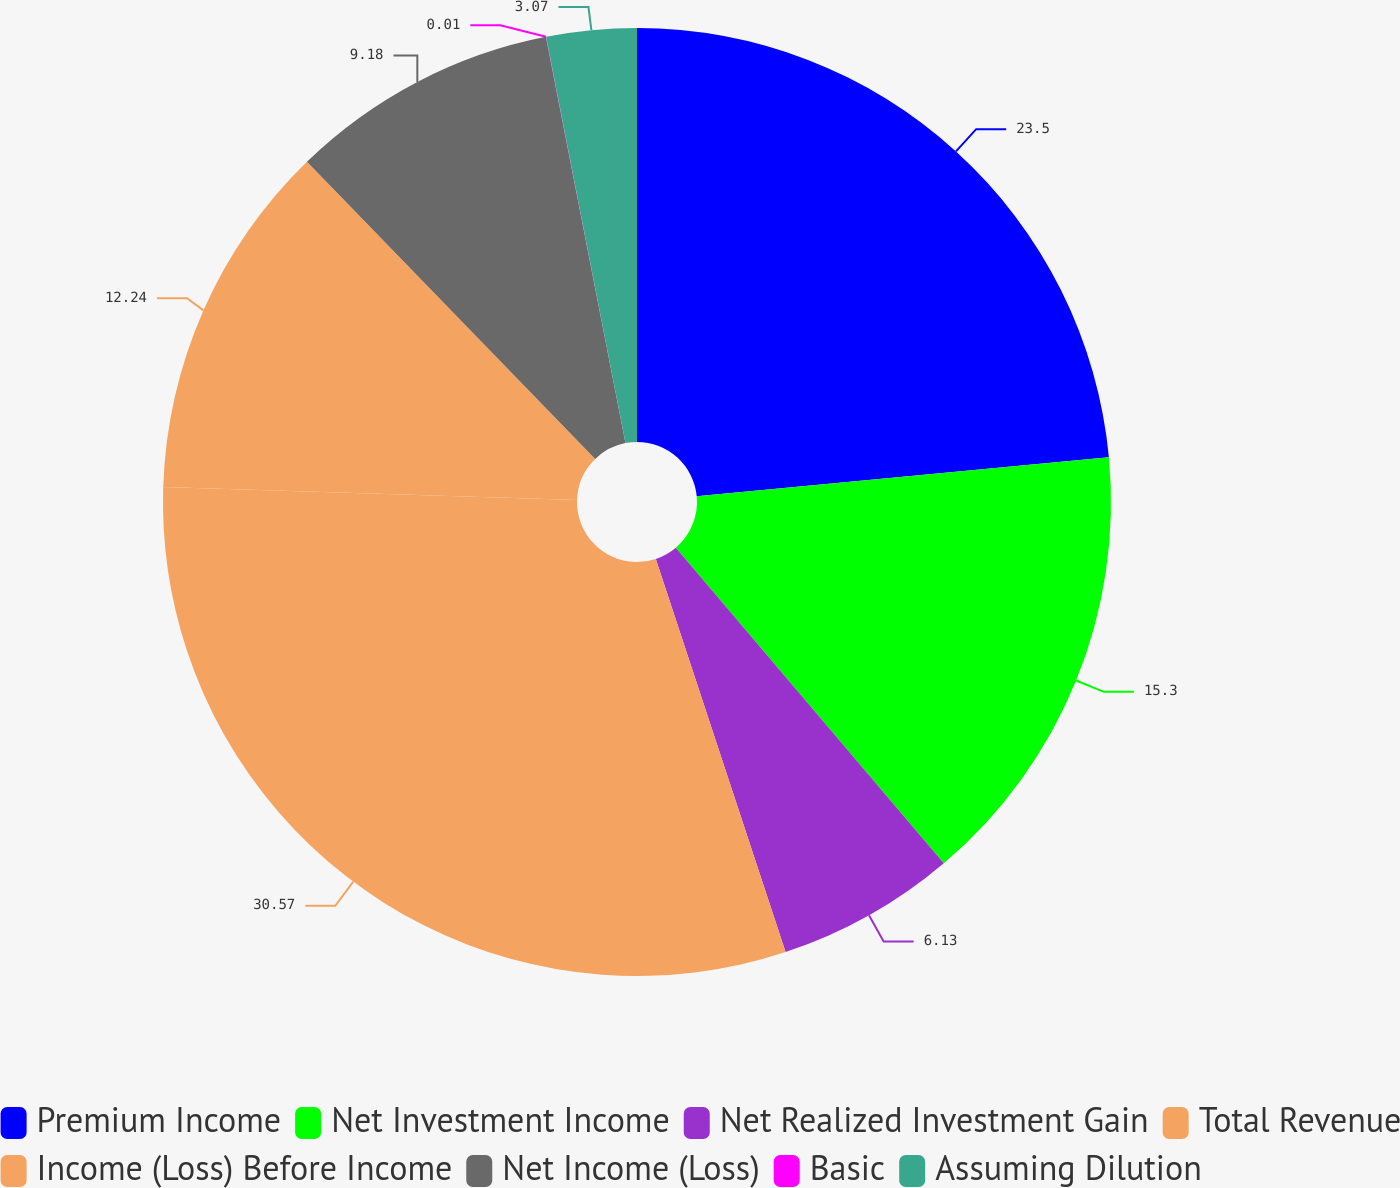Convert chart. <chart><loc_0><loc_0><loc_500><loc_500><pie_chart><fcel>Premium Income<fcel>Net Investment Income<fcel>Net Realized Investment Gain<fcel>Total Revenue<fcel>Income (Loss) Before Income<fcel>Net Income (Loss)<fcel>Basic<fcel>Assuming Dilution<nl><fcel>23.5%<fcel>15.3%<fcel>6.13%<fcel>30.58%<fcel>12.24%<fcel>9.18%<fcel>0.01%<fcel>3.07%<nl></chart> 